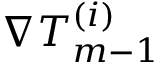Convert formula to latex. <formula><loc_0><loc_0><loc_500><loc_500>\nabla T _ { m - 1 } ^ { ( i ) }</formula> 